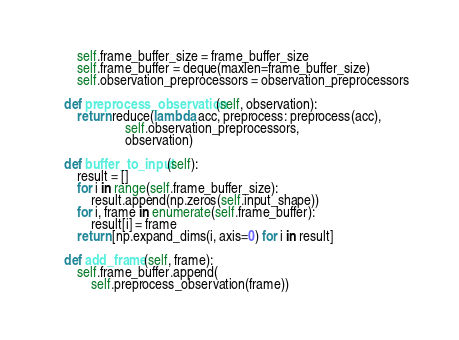<code> <loc_0><loc_0><loc_500><loc_500><_Python_>        self.frame_buffer_size = frame_buffer_size
        self.frame_buffer = deque(maxlen=frame_buffer_size)
        self.observation_preprocessors = observation_preprocessors

    def preprocess_observation(self, observation):
        return reduce(lambda acc, preprocess: preprocess(acc),
                      self.observation_preprocessors,
                      observation)

    def buffer_to_input(self):
        result = []
        for i in range(self.frame_buffer_size):
            result.append(np.zeros(self.input_shape))
        for i, frame in enumerate(self.frame_buffer):
            result[i] = frame
        return [np.expand_dims(i, axis=0) for i in result]

    def add_frame(self, frame):
        self.frame_buffer.append(
            self.preprocess_observation(frame))
</code> 